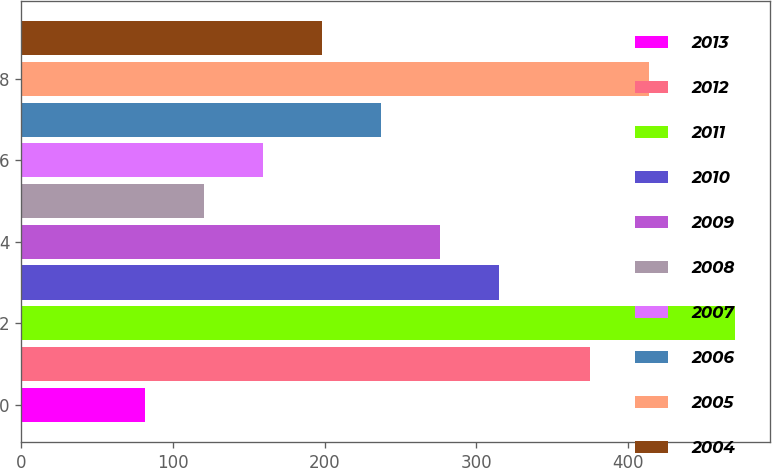Convert chart. <chart><loc_0><loc_0><loc_500><loc_500><bar_chart><fcel>2013<fcel>2012<fcel>2011<fcel>2010<fcel>2009<fcel>2008<fcel>2007<fcel>2006<fcel>2005<fcel>2004<nl><fcel>82<fcel>375<fcel>470<fcel>314.8<fcel>276<fcel>120.8<fcel>159.6<fcel>237.2<fcel>413.8<fcel>198.4<nl></chart> 